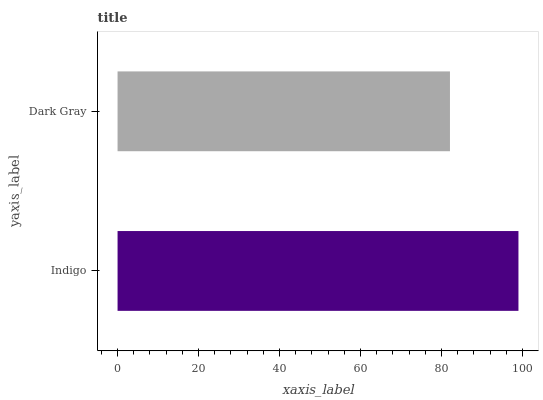Is Dark Gray the minimum?
Answer yes or no. Yes. Is Indigo the maximum?
Answer yes or no. Yes. Is Dark Gray the maximum?
Answer yes or no. No. Is Indigo greater than Dark Gray?
Answer yes or no. Yes. Is Dark Gray less than Indigo?
Answer yes or no. Yes. Is Dark Gray greater than Indigo?
Answer yes or no. No. Is Indigo less than Dark Gray?
Answer yes or no. No. Is Indigo the high median?
Answer yes or no. Yes. Is Dark Gray the low median?
Answer yes or no. Yes. Is Dark Gray the high median?
Answer yes or no. No. Is Indigo the low median?
Answer yes or no. No. 